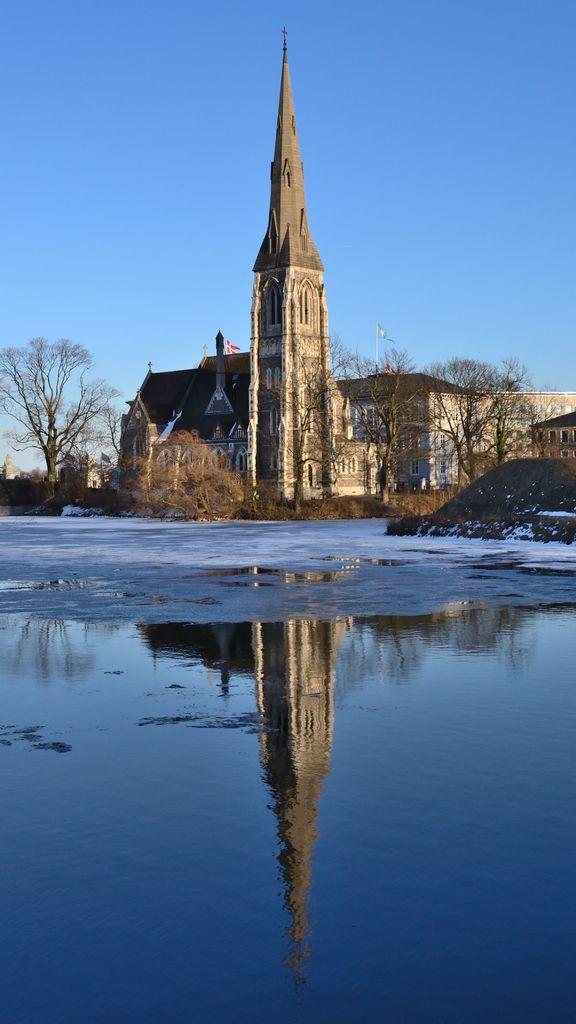Describe this image in one or two sentences. In the image we can see a spire, trees, water and pale blue sky. In the water we can see the reflection of the spire. 